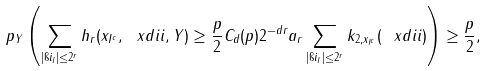<formula> <loc_0><loc_0><loc_500><loc_500>\ p _ { Y } \left ( \sum _ { | \i i _ { I } | \leq 2 ^ { r } } h _ { r } ( x _ { I ^ { c } } , \ x d i i , Y ) \geq \frac { p } { 2 } C _ { d } ( p ) 2 ^ { - d r } a _ { r } \sum _ { | \i i _ { I } | \leq 2 ^ { r } } k _ { 2 , x _ { I ^ { c } } } ( \ x d i i ) \right ) \geq \frac { p } { 2 } ,</formula> 